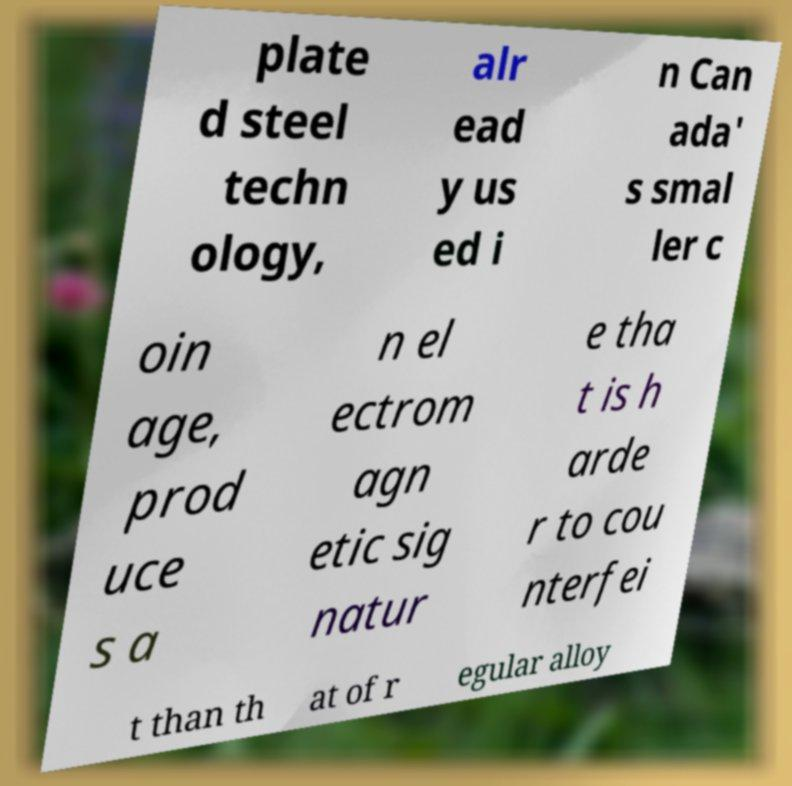Can you accurately transcribe the text from the provided image for me? plate d steel techn ology, alr ead y us ed i n Can ada' s smal ler c oin age, prod uce s a n el ectrom agn etic sig natur e tha t is h arde r to cou nterfei t than th at of r egular alloy 